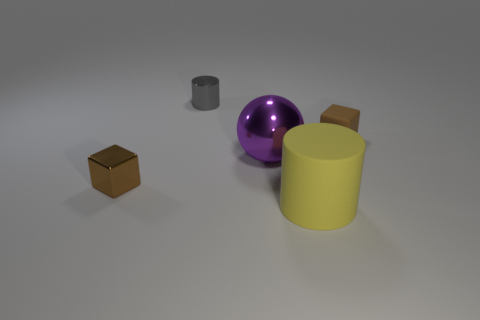What number of other objects are the same size as the yellow matte cylinder?
Your answer should be compact. 1. There is a metal thing that is the same color as the tiny matte block; what size is it?
Make the answer very short. Small. What number of cylinders are brown objects or yellow objects?
Give a very brief answer. 1. There is a small object behind the brown matte object; is its shape the same as the big yellow thing?
Offer a very short reply. Yes. Is the number of large objects in front of the brown shiny object greater than the number of large gray metal spheres?
Keep it short and to the point. Yes. There is a cylinder that is the same size as the sphere; what is its color?
Offer a terse response. Yellow. What number of things are either small brown objects on the left side of the small matte block or metal things?
Your answer should be compact. 3. There is a tiny shiny object that is the same color as the matte block; what shape is it?
Make the answer very short. Cube. There is a small brown block that is behind the small brown cube in front of the tiny rubber block; what is it made of?
Give a very brief answer. Rubber. Are there any gray objects that have the same material as the large purple sphere?
Give a very brief answer. Yes. 